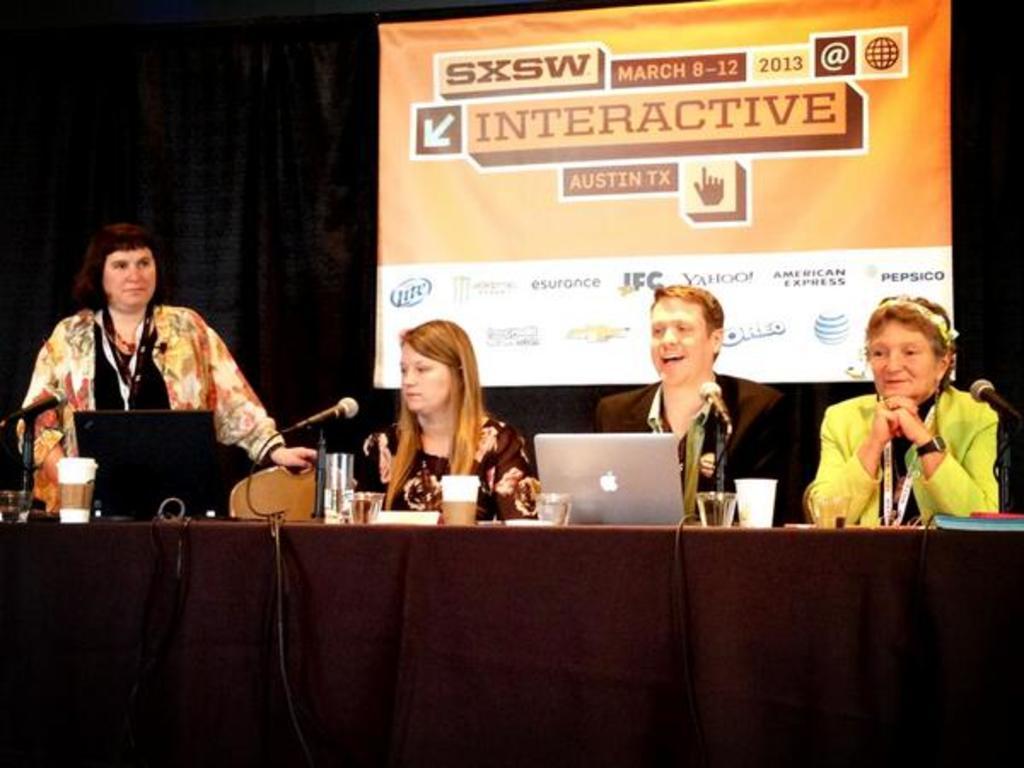Could you give a brief overview of what you see in this image? In this picture we can see three persons siting in front of a table, there are laptops, glasses, microphones and a cloth present on the table, on the left side there is a woman standing, in the background we can see a banner. 